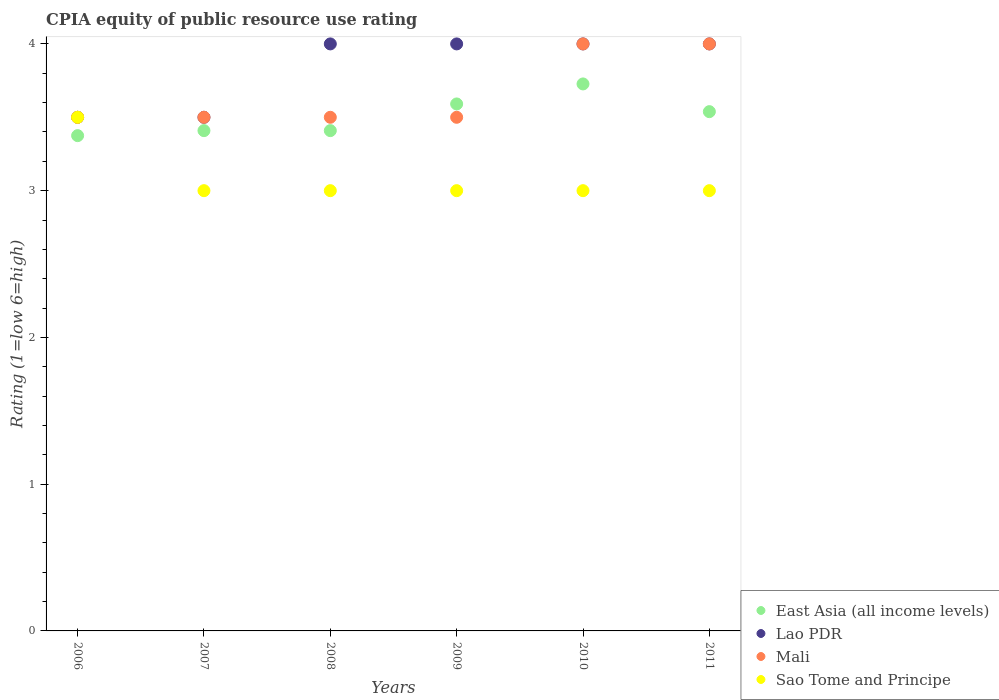What is the CPIA rating in Lao PDR in 2007?
Offer a very short reply. 3.5. Across all years, what is the maximum CPIA rating in East Asia (all income levels)?
Make the answer very short. 3.73. Across all years, what is the minimum CPIA rating in Lao PDR?
Ensure brevity in your answer.  3.5. In which year was the CPIA rating in Sao Tome and Principe maximum?
Your answer should be very brief. 2006. In which year was the CPIA rating in Sao Tome and Principe minimum?
Keep it short and to the point. 2007. What is the total CPIA rating in Mali in the graph?
Keep it short and to the point. 22. What is the difference between the CPIA rating in Mali in 2008 and that in 2009?
Make the answer very short. 0. What is the average CPIA rating in Sao Tome and Principe per year?
Make the answer very short. 3.08. What is the ratio of the CPIA rating in Sao Tome and Principe in 2007 to that in 2008?
Your answer should be very brief. 1. Is the CPIA rating in Mali in 2007 less than that in 2008?
Your response must be concise. No. What is the difference between the highest and the second highest CPIA rating in Sao Tome and Principe?
Your response must be concise. 0.5. How many years are there in the graph?
Offer a terse response. 6. What is the difference between two consecutive major ticks on the Y-axis?
Ensure brevity in your answer.  1. Does the graph contain grids?
Ensure brevity in your answer.  No. Where does the legend appear in the graph?
Give a very brief answer. Bottom right. How many legend labels are there?
Ensure brevity in your answer.  4. What is the title of the graph?
Give a very brief answer. CPIA equity of public resource use rating. Does "Georgia" appear as one of the legend labels in the graph?
Provide a succinct answer. No. What is the Rating (1=low 6=high) in East Asia (all income levels) in 2006?
Your answer should be very brief. 3.38. What is the Rating (1=low 6=high) in Lao PDR in 2006?
Ensure brevity in your answer.  3.5. What is the Rating (1=low 6=high) of East Asia (all income levels) in 2007?
Offer a very short reply. 3.41. What is the Rating (1=low 6=high) of Mali in 2007?
Offer a terse response. 3.5. What is the Rating (1=low 6=high) of Sao Tome and Principe in 2007?
Provide a succinct answer. 3. What is the Rating (1=low 6=high) of East Asia (all income levels) in 2008?
Ensure brevity in your answer.  3.41. What is the Rating (1=low 6=high) of Lao PDR in 2008?
Make the answer very short. 4. What is the Rating (1=low 6=high) of East Asia (all income levels) in 2009?
Your answer should be very brief. 3.59. What is the Rating (1=low 6=high) in Lao PDR in 2009?
Offer a very short reply. 4. What is the Rating (1=low 6=high) of Mali in 2009?
Provide a short and direct response. 3.5. What is the Rating (1=low 6=high) of East Asia (all income levels) in 2010?
Offer a very short reply. 3.73. What is the Rating (1=low 6=high) in Mali in 2010?
Your answer should be very brief. 4. What is the Rating (1=low 6=high) of East Asia (all income levels) in 2011?
Your answer should be very brief. 3.54. What is the Rating (1=low 6=high) in Lao PDR in 2011?
Make the answer very short. 4. Across all years, what is the maximum Rating (1=low 6=high) in East Asia (all income levels)?
Keep it short and to the point. 3.73. Across all years, what is the maximum Rating (1=low 6=high) of Sao Tome and Principe?
Give a very brief answer. 3.5. Across all years, what is the minimum Rating (1=low 6=high) of East Asia (all income levels)?
Your answer should be compact. 3.38. Across all years, what is the minimum Rating (1=low 6=high) in Sao Tome and Principe?
Provide a short and direct response. 3. What is the total Rating (1=low 6=high) in East Asia (all income levels) in the graph?
Offer a terse response. 21.05. What is the total Rating (1=low 6=high) of Mali in the graph?
Provide a short and direct response. 22. What is the difference between the Rating (1=low 6=high) in East Asia (all income levels) in 2006 and that in 2007?
Offer a very short reply. -0.03. What is the difference between the Rating (1=low 6=high) in East Asia (all income levels) in 2006 and that in 2008?
Give a very brief answer. -0.03. What is the difference between the Rating (1=low 6=high) of East Asia (all income levels) in 2006 and that in 2009?
Your answer should be compact. -0.22. What is the difference between the Rating (1=low 6=high) in East Asia (all income levels) in 2006 and that in 2010?
Make the answer very short. -0.35. What is the difference between the Rating (1=low 6=high) in Lao PDR in 2006 and that in 2010?
Ensure brevity in your answer.  -0.5. What is the difference between the Rating (1=low 6=high) in East Asia (all income levels) in 2006 and that in 2011?
Give a very brief answer. -0.16. What is the difference between the Rating (1=low 6=high) of Sao Tome and Principe in 2006 and that in 2011?
Make the answer very short. 0.5. What is the difference between the Rating (1=low 6=high) in East Asia (all income levels) in 2007 and that in 2008?
Give a very brief answer. 0. What is the difference between the Rating (1=low 6=high) in Lao PDR in 2007 and that in 2008?
Keep it short and to the point. -0.5. What is the difference between the Rating (1=low 6=high) in Sao Tome and Principe in 2007 and that in 2008?
Give a very brief answer. 0. What is the difference between the Rating (1=low 6=high) of East Asia (all income levels) in 2007 and that in 2009?
Ensure brevity in your answer.  -0.18. What is the difference between the Rating (1=low 6=high) in Sao Tome and Principe in 2007 and that in 2009?
Provide a succinct answer. 0. What is the difference between the Rating (1=low 6=high) in East Asia (all income levels) in 2007 and that in 2010?
Ensure brevity in your answer.  -0.32. What is the difference between the Rating (1=low 6=high) in Lao PDR in 2007 and that in 2010?
Provide a succinct answer. -0.5. What is the difference between the Rating (1=low 6=high) of Sao Tome and Principe in 2007 and that in 2010?
Offer a terse response. 0. What is the difference between the Rating (1=low 6=high) in East Asia (all income levels) in 2007 and that in 2011?
Provide a succinct answer. -0.13. What is the difference between the Rating (1=low 6=high) in Lao PDR in 2007 and that in 2011?
Provide a short and direct response. -0.5. What is the difference between the Rating (1=low 6=high) of Sao Tome and Principe in 2007 and that in 2011?
Ensure brevity in your answer.  0. What is the difference between the Rating (1=low 6=high) in East Asia (all income levels) in 2008 and that in 2009?
Your answer should be very brief. -0.18. What is the difference between the Rating (1=low 6=high) in Lao PDR in 2008 and that in 2009?
Offer a very short reply. 0. What is the difference between the Rating (1=low 6=high) of Mali in 2008 and that in 2009?
Offer a very short reply. 0. What is the difference between the Rating (1=low 6=high) of Sao Tome and Principe in 2008 and that in 2009?
Your response must be concise. 0. What is the difference between the Rating (1=low 6=high) of East Asia (all income levels) in 2008 and that in 2010?
Give a very brief answer. -0.32. What is the difference between the Rating (1=low 6=high) of East Asia (all income levels) in 2008 and that in 2011?
Provide a succinct answer. -0.13. What is the difference between the Rating (1=low 6=high) of Lao PDR in 2008 and that in 2011?
Keep it short and to the point. 0. What is the difference between the Rating (1=low 6=high) of East Asia (all income levels) in 2009 and that in 2010?
Your answer should be compact. -0.14. What is the difference between the Rating (1=low 6=high) of Lao PDR in 2009 and that in 2010?
Provide a short and direct response. 0. What is the difference between the Rating (1=low 6=high) in Mali in 2009 and that in 2010?
Provide a short and direct response. -0.5. What is the difference between the Rating (1=low 6=high) in Sao Tome and Principe in 2009 and that in 2010?
Make the answer very short. 0. What is the difference between the Rating (1=low 6=high) of East Asia (all income levels) in 2009 and that in 2011?
Offer a very short reply. 0.05. What is the difference between the Rating (1=low 6=high) in Mali in 2009 and that in 2011?
Your response must be concise. -0.5. What is the difference between the Rating (1=low 6=high) of Sao Tome and Principe in 2009 and that in 2011?
Your response must be concise. 0. What is the difference between the Rating (1=low 6=high) of East Asia (all income levels) in 2010 and that in 2011?
Your answer should be compact. 0.19. What is the difference between the Rating (1=low 6=high) in Lao PDR in 2010 and that in 2011?
Offer a very short reply. 0. What is the difference between the Rating (1=low 6=high) in Mali in 2010 and that in 2011?
Make the answer very short. 0. What is the difference between the Rating (1=low 6=high) in East Asia (all income levels) in 2006 and the Rating (1=low 6=high) in Lao PDR in 2007?
Ensure brevity in your answer.  -0.12. What is the difference between the Rating (1=low 6=high) in East Asia (all income levels) in 2006 and the Rating (1=low 6=high) in Mali in 2007?
Your response must be concise. -0.12. What is the difference between the Rating (1=low 6=high) of East Asia (all income levels) in 2006 and the Rating (1=low 6=high) of Lao PDR in 2008?
Provide a short and direct response. -0.62. What is the difference between the Rating (1=low 6=high) of East Asia (all income levels) in 2006 and the Rating (1=low 6=high) of Mali in 2008?
Offer a terse response. -0.12. What is the difference between the Rating (1=low 6=high) of East Asia (all income levels) in 2006 and the Rating (1=low 6=high) of Sao Tome and Principe in 2008?
Give a very brief answer. 0.38. What is the difference between the Rating (1=low 6=high) in Lao PDR in 2006 and the Rating (1=low 6=high) in Mali in 2008?
Ensure brevity in your answer.  0. What is the difference between the Rating (1=low 6=high) in East Asia (all income levels) in 2006 and the Rating (1=low 6=high) in Lao PDR in 2009?
Provide a short and direct response. -0.62. What is the difference between the Rating (1=low 6=high) in East Asia (all income levels) in 2006 and the Rating (1=low 6=high) in Mali in 2009?
Make the answer very short. -0.12. What is the difference between the Rating (1=low 6=high) of East Asia (all income levels) in 2006 and the Rating (1=low 6=high) of Sao Tome and Principe in 2009?
Your response must be concise. 0.38. What is the difference between the Rating (1=low 6=high) of Lao PDR in 2006 and the Rating (1=low 6=high) of Sao Tome and Principe in 2009?
Your response must be concise. 0.5. What is the difference between the Rating (1=low 6=high) of East Asia (all income levels) in 2006 and the Rating (1=low 6=high) of Lao PDR in 2010?
Give a very brief answer. -0.62. What is the difference between the Rating (1=low 6=high) of East Asia (all income levels) in 2006 and the Rating (1=low 6=high) of Mali in 2010?
Make the answer very short. -0.62. What is the difference between the Rating (1=low 6=high) of East Asia (all income levels) in 2006 and the Rating (1=low 6=high) of Sao Tome and Principe in 2010?
Your response must be concise. 0.38. What is the difference between the Rating (1=low 6=high) of Lao PDR in 2006 and the Rating (1=low 6=high) of Sao Tome and Principe in 2010?
Provide a succinct answer. 0.5. What is the difference between the Rating (1=low 6=high) in East Asia (all income levels) in 2006 and the Rating (1=low 6=high) in Lao PDR in 2011?
Offer a terse response. -0.62. What is the difference between the Rating (1=low 6=high) in East Asia (all income levels) in 2006 and the Rating (1=low 6=high) in Mali in 2011?
Offer a terse response. -0.62. What is the difference between the Rating (1=low 6=high) in East Asia (all income levels) in 2006 and the Rating (1=low 6=high) in Sao Tome and Principe in 2011?
Keep it short and to the point. 0.38. What is the difference between the Rating (1=low 6=high) of Mali in 2006 and the Rating (1=low 6=high) of Sao Tome and Principe in 2011?
Keep it short and to the point. 0.5. What is the difference between the Rating (1=low 6=high) of East Asia (all income levels) in 2007 and the Rating (1=low 6=high) of Lao PDR in 2008?
Your response must be concise. -0.59. What is the difference between the Rating (1=low 6=high) of East Asia (all income levels) in 2007 and the Rating (1=low 6=high) of Mali in 2008?
Your response must be concise. -0.09. What is the difference between the Rating (1=low 6=high) of East Asia (all income levels) in 2007 and the Rating (1=low 6=high) of Sao Tome and Principe in 2008?
Ensure brevity in your answer.  0.41. What is the difference between the Rating (1=low 6=high) of Lao PDR in 2007 and the Rating (1=low 6=high) of Sao Tome and Principe in 2008?
Keep it short and to the point. 0.5. What is the difference between the Rating (1=low 6=high) in East Asia (all income levels) in 2007 and the Rating (1=low 6=high) in Lao PDR in 2009?
Give a very brief answer. -0.59. What is the difference between the Rating (1=low 6=high) of East Asia (all income levels) in 2007 and the Rating (1=low 6=high) of Mali in 2009?
Make the answer very short. -0.09. What is the difference between the Rating (1=low 6=high) in East Asia (all income levels) in 2007 and the Rating (1=low 6=high) in Sao Tome and Principe in 2009?
Provide a short and direct response. 0.41. What is the difference between the Rating (1=low 6=high) of Lao PDR in 2007 and the Rating (1=low 6=high) of Mali in 2009?
Your answer should be compact. 0. What is the difference between the Rating (1=low 6=high) of Lao PDR in 2007 and the Rating (1=low 6=high) of Sao Tome and Principe in 2009?
Your answer should be very brief. 0.5. What is the difference between the Rating (1=low 6=high) of Mali in 2007 and the Rating (1=low 6=high) of Sao Tome and Principe in 2009?
Keep it short and to the point. 0.5. What is the difference between the Rating (1=low 6=high) in East Asia (all income levels) in 2007 and the Rating (1=low 6=high) in Lao PDR in 2010?
Your response must be concise. -0.59. What is the difference between the Rating (1=low 6=high) in East Asia (all income levels) in 2007 and the Rating (1=low 6=high) in Mali in 2010?
Your answer should be compact. -0.59. What is the difference between the Rating (1=low 6=high) in East Asia (all income levels) in 2007 and the Rating (1=low 6=high) in Sao Tome and Principe in 2010?
Ensure brevity in your answer.  0.41. What is the difference between the Rating (1=low 6=high) in East Asia (all income levels) in 2007 and the Rating (1=low 6=high) in Lao PDR in 2011?
Give a very brief answer. -0.59. What is the difference between the Rating (1=low 6=high) in East Asia (all income levels) in 2007 and the Rating (1=low 6=high) in Mali in 2011?
Ensure brevity in your answer.  -0.59. What is the difference between the Rating (1=low 6=high) of East Asia (all income levels) in 2007 and the Rating (1=low 6=high) of Sao Tome and Principe in 2011?
Keep it short and to the point. 0.41. What is the difference between the Rating (1=low 6=high) in Lao PDR in 2007 and the Rating (1=low 6=high) in Sao Tome and Principe in 2011?
Provide a short and direct response. 0.5. What is the difference between the Rating (1=low 6=high) in East Asia (all income levels) in 2008 and the Rating (1=low 6=high) in Lao PDR in 2009?
Your answer should be very brief. -0.59. What is the difference between the Rating (1=low 6=high) in East Asia (all income levels) in 2008 and the Rating (1=low 6=high) in Mali in 2009?
Your response must be concise. -0.09. What is the difference between the Rating (1=low 6=high) in East Asia (all income levels) in 2008 and the Rating (1=low 6=high) in Sao Tome and Principe in 2009?
Ensure brevity in your answer.  0.41. What is the difference between the Rating (1=low 6=high) of East Asia (all income levels) in 2008 and the Rating (1=low 6=high) of Lao PDR in 2010?
Provide a succinct answer. -0.59. What is the difference between the Rating (1=low 6=high) in East Asia (all income levels) in 2008 and the Rating (1=low 6=high) in Mali in 2010?
Keep it short and to the point. -0.59. What is the difference between the Rating (1=low 6=high) of East Asia (all income levels) in 2008 and the Rating (1=low 6=high) of Sao Tome and Principe in 2010?
Offer a terse response. 0.41. What is the difference between the Rating (1=low 6=high) in Lao PDR in 2008 and the Rating (1=low 6=high) in Sao Tome and Principe in 2010?
Make the answer very short. 1. What is the difference between the Rating (1=low 6=high) in Mali in 2008 and the Rating (1=low 6=high) in Sao Tome and Principe in 2010?
Your answer should be compact. 0.5. What is the difference between the Rating (1=low 6=high) of East Asia (all income levels) in 2008 and the Rating (1=low 6=high) of Lao PDR in 2011?
Provide a succinct answer. -0.59. What is the difference between the Rating (1=low 6=high) of East Asia (all income levels) in 2008 and the Rating (1=low 6=high) of Mali in 2011?
Ensure brevity in your answer.  -0.59. What is the difference between the Rating (1=low 6=high) of East Asia (all income levels) in 2008 and the Rating (1=low 6=high) of Sao Tome and Principe in 2011?
Offer a terse response. 0.41. What is the difference between the Rating (1=low 6=high) of Mali in 2008 and the Rating (1=low 6=high) of Sao Tome and Principe in 2011?
Make the answer very short. 0.5. What is the difference between the Rating (1=low 6=high) of East Asia (all income levels) in 2009 and the Rating (1=low 6=high) of Lao PDR in 2010?
Provide a succinct answer. -0.41. What is the difference between the Rating (1=low 6=high) in East Asia (all income levels) in 2009 and the Rating (1=low 6=high) in Mali in 2010?
Offer a very short reply. -0.41. What is the difference between the Rating (1=low 6=high) in East Asia (all income levels) in 2009 and the Rating (1=low 6=high) in Sao Tome and Principe in 2010?
Make the answer very short. 0.59. What is the difference between the Rating (1=low 6=high) of Lao PDR in 2009 and the Rating (1=low 6=high) of Mali in 2010?
Give a very brief answer. 0. What is the difference between the Rating (1=low 6=high) of Lao PDR in 2009 and the Rating (1=low 6=high) of Sao Tome and Principe in 2010?
Your answer should be compact. 1. What is the difference between the Rating (1=low 6=high) of East Asia (all income levels) in 2009 and the Rating (1=low 6=high) of Lao PDR in 2011?
Your answer should be very brief. -0.41. What is the difference between the Rating (1=low 6=high) of East Asia (all income levels) in 2009 and the Rating (1=low 6=high) of Mali in 2011?
Keep it short and to the point. -0.41. What is the difference between the Rating (1=low 6=high) in East Asia (all income levels) in 2009 and the Rating (1=low 6=high) in Sao Tome and Principe in 2011?
Ensure brevity in your answer.  0.59. What is the difference between the Rating (1=low 6=high) of Lao PDR in 2009 and the Rating (1=low 6=high) of Mali in 2011?
Offer a terse response. 0. What is the difference between the Rating (1=low 6=high) in Mali in 2009 and the Rating (1=low 6=high) in Sao Tome and Principe in 2011?
Offer a very short reply. 0.5. What is the difference between the Rating (1=low 6=high) in East Asia (all income levels) in 2010 and the Rating (1=low 6=high) in Lao PDR in 2011?
Your answer should be compact. -0.27. What is the difference between the Rating (1=low 6=high) in East Asia (all income levels) in 2010 and the Rating (1=low 6=high) in Mali in 2011?
Your answer should be compact. -0.27. What is the difference between the Rating (1=low 6=high) of East Asia (all income levels) in 2010 and the Rating (1=low 6=high) of Sao Tome and Principe in 2011?
Provide a succinct answer. 0.73. What is the difference between the Rating (1=low 6=high) of Lao PDR in 2010 and the Rating (1=low 6=high) of Sao Tome and Principe in 2011?
Provide a succinct answer. 1. What is the difference between the Rating (1=low 6=high) in Mali in 2010 and the Rating (1=low 6=high) in Sao Tome and Principe in 2011?
Your answer should be very brief. 1. What is the average Rating (1=low 6=high) in East Asia (all income levels) per year?
Your answer should be compact. 3.51. What is the average Rating (1=low 6=high) of Lao PDR per year?
Provide a short and direct response. 3.83. What is the average Rating (1=low 6=high) of Mali per year?
Ensure brevity in your answer.  3.67. What is the average Rating (1=low 6=high) in Sao Tome and Principe per year?
Provide a short and direct response. 3.08. In the year 2006, what is the difference between the Rating (1=low 6=high) in East Asia (all income levels) and Rating (1=low 6=high) in Lao PDR?
Your answer should be compact. -0.12. In the year 2006, what is the difference between the Rating (1=low 6=high) of East Asia (all income levels) and Rating (1=low 6=high) of Mali?
Offer a very short reply. -0.12. In the year 2006, what is the difference between the Rating (1=low 6=high) of East Asia (all income levels) and Rating (1=low 6=high) of Sao Tome and Principe?
Your response must be concise. -0.12. In the year 2006, what is the difference between the Rating (1=low 6=high) in Lao PDR and Rating (1=low 6=high) in Mali?
Your answer should be compact. 0. In the year 2006, what is the difference between the Rating (1=low 6=high) in Lao PDR and Rating (1=low 6=high) in Sao Tome and Principe?
Keep it short and to the point. 0. In the year 2007, what is the difference between the Rating (1=low 6=high) in East Asia (all income levels) and Rating (1=low 6=high) in Lao PDR?
Make the answer very short. -0.09. In the year 2007, what is the difference between the Rating (1=low 6=high) in East Asia (all income levels) and Rating (1=low 6=high) in Mali?
Give a very brief answer. -0.09. In the year 2007, what is the difference between the Rating (1=low 6=high) of East Asia (all income levels) and Rating (1=low 6=high) of Sao Tome and Principe?
Make the answer very short. 0.41. In the year 2008, what is the difference between the Rating (1=low 6=high) in East Asia (all income levels) and Rating (1=low 6=high) in Lao PDR?
Provide a succinct answer. -0.59. In the year 2008, what is the difference between the Rating (1=low 6=high) in East Asia (all income levels) and Rating (1=low 6=high) in Mali?
Give a very brief answer. -0.09. In the year 2008, what is the difference between the Rating (1=low 6=high) in East Asia (all income levels) and Rating (1=low 6=high) in Sao Tome and Principe?
Your answer should be compact. 0.41. In the year 2008, what is the difference between the Rating (1=low 6=high) of Lao PDR and Rating (1=low 6=high) of Sao Tome and Principe?
Offer a very short reply. 1. In the year 2008, what is the difference between the Rating (1=low 6=high) of Mali and Rating (1=low 6=high) of Sao Tome and Principe?
Give a very brief answer. 0.5. In the year 2009, what is the difference between the Rating (1=low 6=high) of East Asia (all income levels) and Rating (1=low 6=high) of Lao PDR?
Offer a very short reply. -0.41. In the year 2009, what is the difference between the Rating (1=low 6=high) in East Asia (all income levels) and Rating (1=low 6=high) in Mali?
Your answer should be compact. 0.09. In the year 2009, what is the difference between the Rating (1=low 6=high) in East Asia (all income levels) and Rating (1=low 6=high) in Sao Tome and Principe?
Your response must be concise. 0.59. In the year 2009, what is the difference between the Rating (1=low 6=high) of Lao PDR and Rating (1=low 6=high) of Mali?
Your answer should be compact. 0.5. In the year 2009, what is the difference between the Rating (1=low 6=high) in Mali and Rating (1=low 6=high) in Sao Tome and Principe?
Offer a very short reply. 0.5. In the year 2010, what is the difference between the Rating (1=low 6=high) in East Asia (all income levels) and Rating (1=low 6=high) in Lao PDR?
Make the answer very short. -0.27. In the year 2010, what is the difference between the Rating (1=low 6=high) of East Asia (all income levels) and Rating (1=low 6=high) of Mali?
Offer a terse response. -0.27. In the year 2010, what is the difference between the Rating (1=low 6=high) in East Asia (all income levels) and Rating (1=low 6=high) in Sao Tome and Principe?
Ensure brevity in your answer.  0.73. In the year 2010, what is the difference between the Rating (1=low 6=high) in Mali and Rating (1=low 6=high) in Sao Tome and Principe?
Offer a very short reply. 1. In the year 2011, what is the difference between the Rating (1=low 6=high) of East Asia (all income levels) and Rating (1=low 6=high) of Lao PDR?
Keep it short and to the point. -0.46. In the year 2011, what is the difference between the Rating (1=low 6=high) in East Asia (all income levels) and Rating (1=low 6=high) in Mali?
Your answer should be very brief. -0.46. In the year 2011, what is the difference between the Rating (1=low 6=high) of East Asia (all income levels) and Rating (1=low 6=high) of Sao Tome and Principe?
Ensure brevity in your answer.  0.54. In the year 2011, what is the difference between the Rating (1=low 6=high) in Lao PDR and Rating (1=low 6=high) in Mali?
Give a very brief answer. 0. In the year 2011, what is the difference between the Rating (1=low 6=high) of Mali and Rating (1=low 6=high) of Sao Tome and Principe?
Give a very brief answer. 1. What is the ratio of the Rating (1=low 6=high) in Lao PDR in 2006 to that in 2007?
Your answer should be very brief. 1. What is the ratio of the Rating (1=low 6=high) of Lao PDR in 2006 to that in 2008?
Your response must be concise. 0.88. What is the ratio of the Rating (1=low 6=high) of Sao Tome and Principe in 2006 to that in 2008?
Provide a succinct answer. 1.17. What is the ratio of the Rating (1=low 6=high) of East Asia (all income levels) in 2006 to that in 2009?
Give a very brief answer. 0.94. What is the ratio of the Rating (1=low 6=high) of East Asia (all income levels) in 2006 to that in 2010?
Give a very brief answer. 0.91. What is the ratio of the Rating (1=low 6=high) of Lao PDR in 2006 to that in 2010?
Provide a short and direct response. 0.88. What is the ratio of the Rating (1=low 6=high) in Sao Tome and Principe in 2006 to that in 2010?
Provide a succinct answer. 1.17. What is the ratio of the Rating (1=low 6=high) in East Asia (all income levels) in 2006 to that in 2011?
Your response must be concise. 0.95. What is the ratio of the Rating (1=low 6=high) of Mali in 2006 to that in 2011?
Provide a short and direct response. 0.88. What is the ratio of the Rating (1=low 6=high) of East Asia (all income levels) in 2007 to that in 2008?
Your answer should be very brief. 1. What is the ratio of the Rating (1=low 6=high) of East Asia (all income levels) in 2007 to that in 2009?
Your answer should be very brief. 0.95. What is the ratio of the Rating (1=low 6=high) of Mali in 2007 to that in 2009?
Offer a terse response. 1. What is the ratio of the Rating (1=low 6=high) of East Asia (all income levels) in 2007 to that in 2010?
Make the answer very short. 0.91. What is the ratio of the Rating (1=low 6=high) in East Asia (all income levels) in 2007 to that in 2011?
Ensure brevity in your answer.  0.96. What is the ratio of the Rating (1=low 6=high) in Mali in 2007 to that in 2011?
Provide a succinct answer. 0.88. What is the ratio of the Rating (1=low 6=high) of East Asia (all income levels) in 2008 to that in 2009?
Offer a very short reply. 0.95. What is the ratio of the Rating (1=low 6=high) of Sao Tome and Principe in 2008 to that in 2009?
Make the answer very short. 1. What is the ratio of the Rating (1=low 6=high) of East Asia (all income levels) in 2008 to that in 2010?
Give a very brief answer. 0.91. What is the ratio of the Rating (1=low 6=high) in Sao Tome and Principe in 2008 to that in 2010?
Give a very brief answer. 1. What is the ratio of the Rating (1=low 6=high) in East Asia (all income levels) in 2008 to that in 2011?
Your response must be concise. 0.96. What is the ratio of the Rating (1=low 6=high) of Lao PDR in 2008 to that in 2011?
Your response must be concise. 1. What is the ratio of the Rating (1=low 6=high) of Mali in 2008 to that in 2011?
Ensure brevity in your answer.  0.88. What is the ratio of the Rating (1=low 6=high) in East Asia (all income levels) in 2009 to that in 2010?
Ensure brevity in your answer.  0.96. What is the ratio of the Rating (1=low 6=high) of Mali in 2009 to that in 2010?
Keep it short and to the point. 0.88. What is the ratio of the Rating (1=low 6=high) of Sao Tome and Principe in 2009 to that in 2010?
Your answer should be very brief. 1. What is the ratio of the Rating (1=low 6=high) in East Asia (all income levels) in 2009 to that in 2011?
Provide a succinct answer. 1.01. What is the ratio of the Rating (1=low 6=high) in Sao Tome and Principe in 2009 to that in 2011?
Your response must be concise. 1. What is the ratio of the Rating (1=low 6=high) in East Asia (all income levels) in 2010 to that in 2011?
Keep it short and to the point. 1.05. What is the ratio of the Rating (1=low 6=high) in Mali in 2010 to that in 2011?
Keep it short and to the point. 1. What is the difference between the highest and the second highest Rating (1=low 6=high) of East Asia (all income levels)?
Give a very brief answer. 0.14. What is the difference between the highest and the second highest Rating (1=low 6=high) of Mali?
Your answer should be compact. 0. What is the difference between the highest and the lowest Rating (1=low 6=high) of East Asia (all income levels)?
Ensure brevity in your answer.  0.35. 